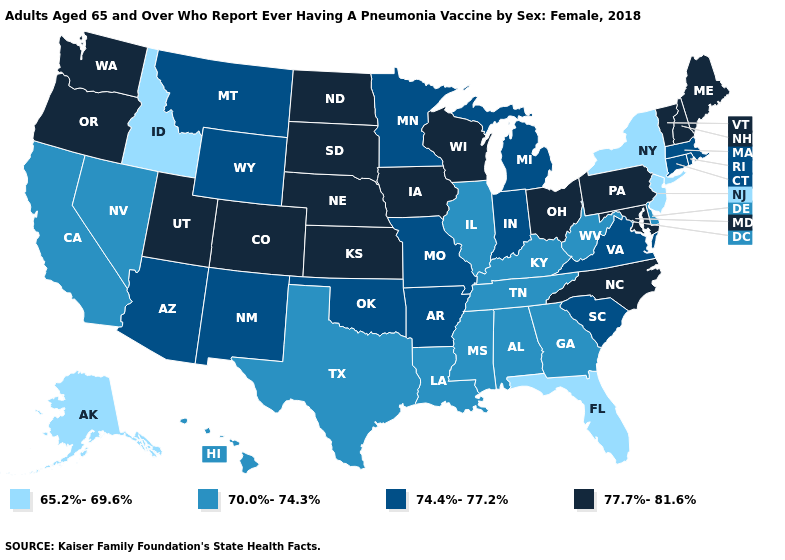Name the states that have a value in the range 70.0%-74.3%?
Write a very short answer. Alabama, California, Delaware, Georgia, Hawaii, Illinois, Kentucky, Louisiana, Mississippi, Nevada, Tennessee, Texas, West Virginia. Name the states that have a value in the range 74.4%-77.2%?
Short answer required. Arizona, Arkansas, Connecticut, Indiana, Massachusetts, Michigan, Minnesota, Missouri, Montana, New Mexico, Oklahoma, Rhode Island, South Carolina, Virginia, Wyoming. Name the states that have a value in the range 74.4%-77.2%?
Short answer required. Arizona, Arkansas, Connecticut, Indiana, Massachusetts, Michigan, Minnesota, Missouri, Montana, New Mexico, Oklahoma, Rhode Island, South Carolina, Virginia, Wyoming. What is the lowest value in states that border Virginia?
Give a very brief answer. 70.0%-74.3%. Does Mississippi have the lowest value in the USA?
Write a very short answer. No. Name the states that have a value in the range 70.0%-74.3%?
Write a very short answer. Alabama, California, Delaware, Georgia, Hawaii, Illinois, Kentucky, Louisiana, Mississippi, Nevada, Tennessee, Texas, West Virginia. What is the lowest value in the MidWest?
Answer briefly. 70.0%-74.3%. Name the states that have a value in the range 74.4%-77.2%?
Be succinct. Arizona, Arkansas, Connecticut, Indiana, Massachusetts, Michigan, Minnesota, Missouri, Montana, New Mexico, Oklahoma, Rhode Island, South Carolina, Virginia, Wyoming. Does West Virginia have a lower value than Hawaii?
Give a very brief answer. No. Name the states that have a value in the range 77.7%-81.6%?
Give a very brief answer. Colorado, Iowa, Kansas, Maine, Maryland, Nebraska, New Hampshire, North Carolina, North Dakota, Ohio, Oregon, Pennsylvania, South Dakota, Utah, Vermont, Washington, Wisconsin. Among the states that border Arizona , does New Mexico have the lowest value?
Answer briefly. No. Does the first symbol in the legend represent the smallest category?
Give a very brief answer. Yes. Name the states that have a value in the range 65.2%-69.6%?
Write a very short answer. Alaska, Florida, Idaho, New Jersey, New York. What is the highest value in the USA?
Be succinct. 77.7%-81.6%. 